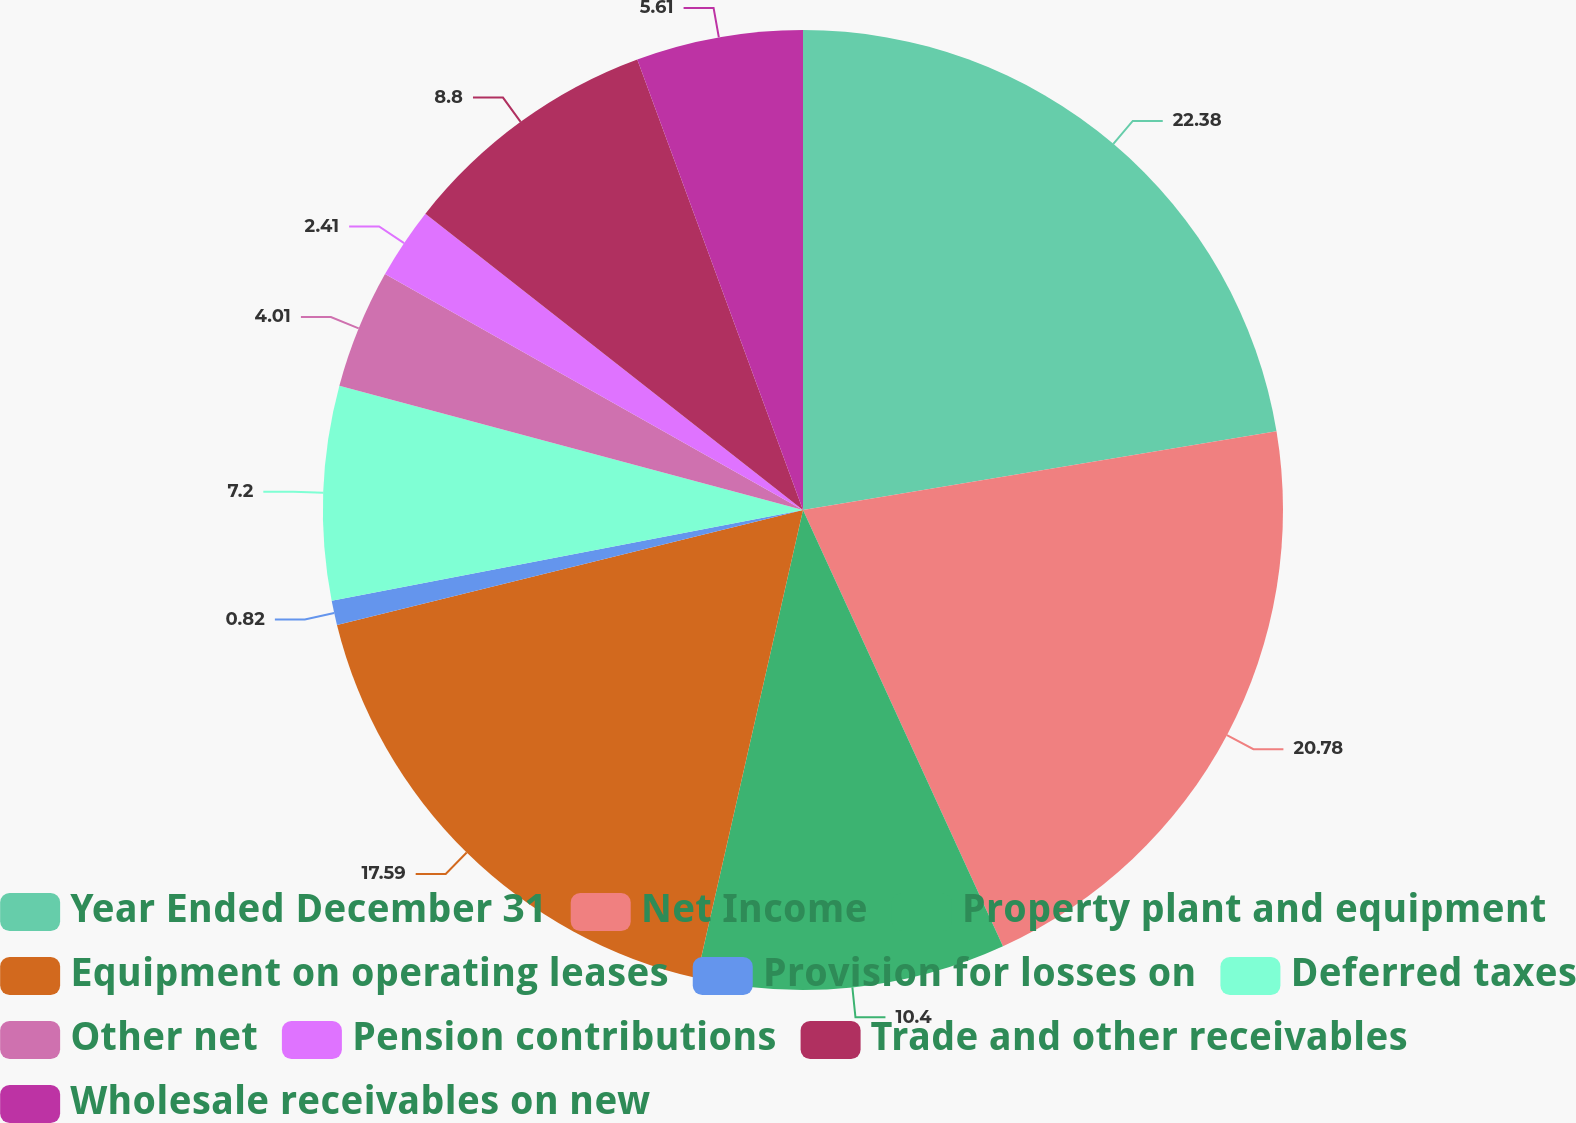Convert chart to OTSL. <chart><loc_0><loc_0><loc_500><loc_500><pie_chart><fcel>Year Ended December 31<fcel>Net Income<fcel>Property plant and equipment<fcel>Equipment on operating leases<fcel>Provision for losses on<fcel>Deferred taxes<fcel>Other net<fcel>Pension contributions<fcel>Trade and other receivables<fcel>Wholesale receivables on new<nl><fcel>22.38%<fcel>20.78%<fcel>10.4%<fcel>17.59%<fcel>0.82%<fcel>7.2%<fcel>4.01%<fcel>2.41%<fcel>8.8%<fcel>5.61%<nl></chart> 